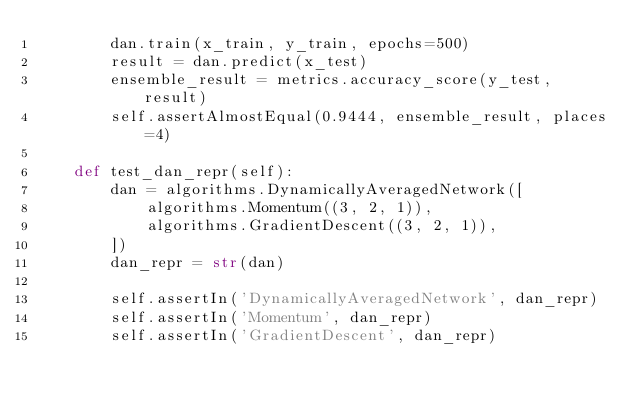<code> <loc_0><loc_0><loc_500><loc_500><_Python_>        dan.train(x_train, y_train, epochs=500)
        result = dan.predict(x_test)
        ensemble_result = metrics.accuracy_score(y_test, result)
        self.assertAlmostEqual(0.9444, ensemble_result, places=4)

    def test_dan_repr(self):
        dan = algorithms.DynamicallyAveragedNetwork([
            algorithms.Momentum((3, 2, 1)),
            algorithms.GradientDescent((3, 2, 1)),
        ])
        dan_repr = str(dan)

        self.assertIn('DynamicallyAveragedNetwork', dan_repr)
        self.assertIn('Momentum', dan_repr)
        self.assertIn('GradientDescent', dan_repr)
</code> 